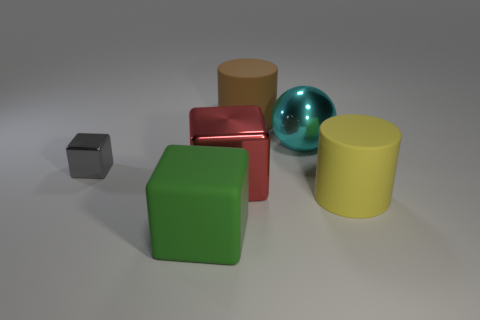Is there anything else that is the same size as the gray thing?
Ensure brevity in your answer.  No. What is the shape of the big matte thing that is behind the big cylinder that is on the right side of the cylinder on the left side of the big cyan sphere?
Your answer should be compact. Cylinder. Is the number of large red objects in front of the big cyan sphere less than the number of blocks that are behind the rubber block?
Give a very brief answer. Yes. There is a big metallic thing that is right of the big shiny thing to the left of the large brown cylinder; what shape is it?
Offer a very short reply. Sphere. Are there any other things that have the same color as the big matte cube?
Keep it short and to the point. No. Does the ball have the same color as the tiny cube?
Provide a succinct answer. No. How many red objects are small matte blocks or big cubes?
Your answer should be very brief. 1. Are there fewer blocks that are behind the small gray metal thing than cylinders?
Offer a very short reply. Yes. How many big cyan balls are on the left side of the large rubber object that is behind the big yellow rubber thing?
Your answer should be very brief. 0. What number of other objects are there of the same size as the red metallic cube?
Give a very brief answer. 4. 